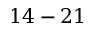Convert formula to latex. <formula><loc_0><loc_0><loc_500><loc_500>1 4 - 2 1</formula> 